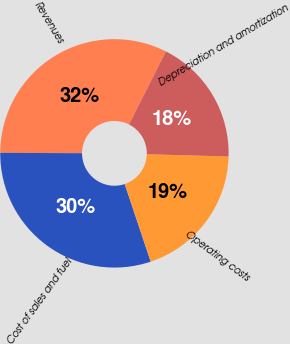<chart> <loc_0><loc_0><loc_500><loc_500><pie_chart><fcel>Revenues<fcel>Cost of sales and fuel<fcel>Operating costs<fcel>Depreciation and amortization<nl><fcel>32.37%<fcel>30.22%<fcel>19.42%<fcel>17.99%<nl></chart> 